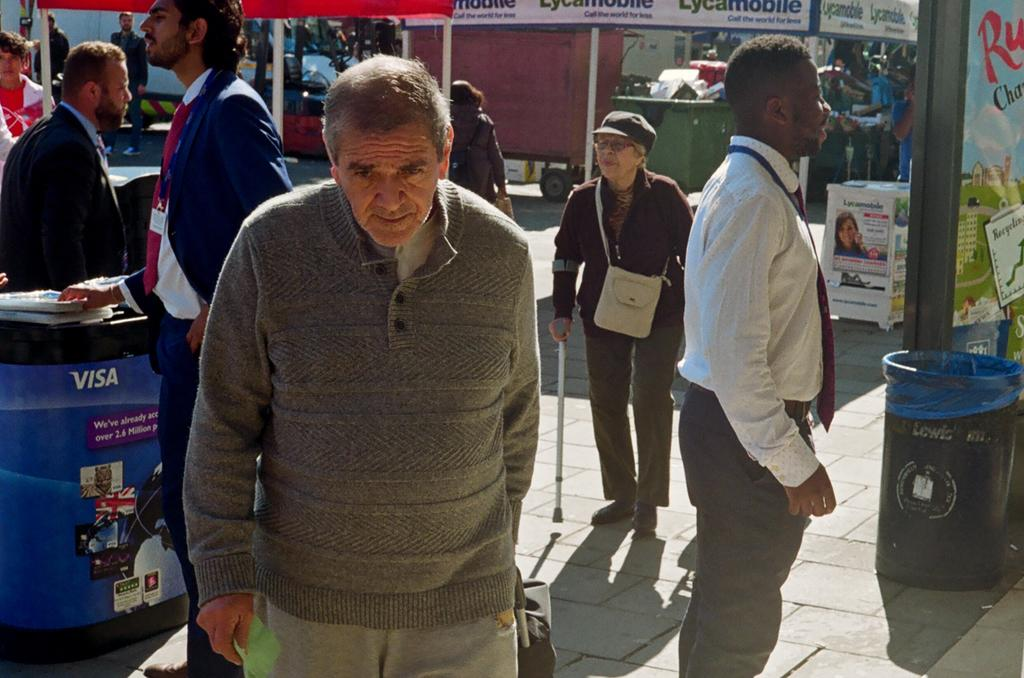What are the people in the image doing? The group of people is standing on the ground in the image. What can be seen near the people? There is a bin in the image. What items are visible in the image besides the people and the bin? There are books, poles, and banners in the image. What can be seen in the background of the image? There are objects visible in the background of the image. What type of coal can be seen in the image? There is no coal present in the image. What is the texture of the grass in the image? There is no grass present in the image. 